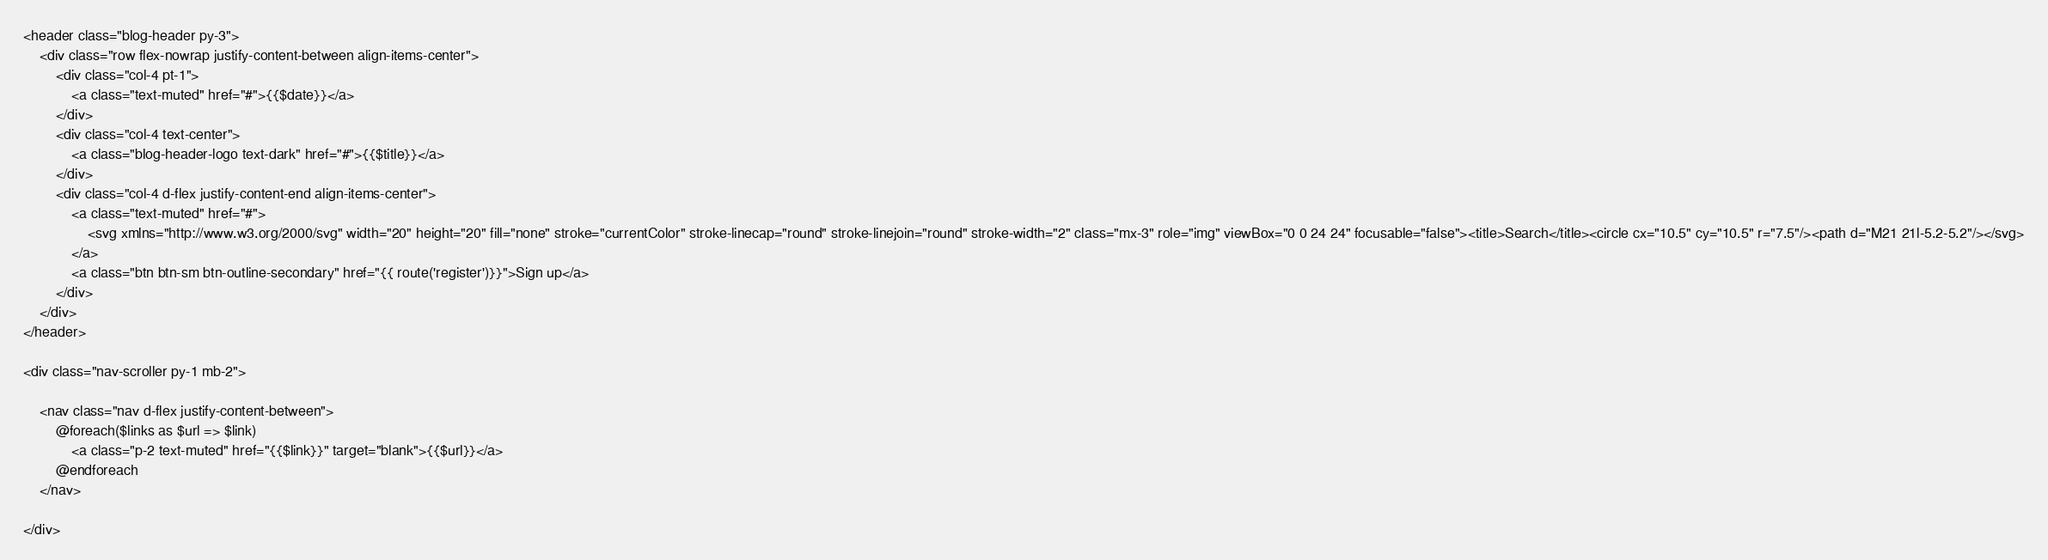<code> <loc_0><loc_0><loc_500><loc_500><_PHP_><header class="blog-header py-3">
    <div class="row flex-nowrap justify-content-between align-items-center">
        <div class="col-4 pt-1">
            <a class="text-muted" href="#">{{$date}}</a>
        </div>
        <div class="col-4 text-center">
            <a class="blog-header-logo text-dark" href="#">{{$title}}</a>
        </div>
        <div class="col-4 d-flex justify-content-end align-items-center">
            <a class="text-muted" href="#">
                <svg xmlns="http://www.w3.org/2000/svg" width="20" height="20" fill="none" stroke="currentColor" stroke-linecap="round" stroke-linejoin="round" stroke-width="2" class="mx-3" role="img" viewBox="0 0 24 24" focusable="false"><title>Search</title><circle cx="10.5" cy="10.5" r="7.5"/><path d="M21 21l-5.2-5.2"/></svg>
            </a>
            <a class="btn btn-sm btn-outline-secondary" href="{{ route('register')}}">Sign up</a>
        </div>
    </div>
</header>

<div class="nav-scroller py-1 mb-2">

    <nav class="nav d-flex justify-content-between">
        @foreach($links as $url => $link)
            <a class="p-2 text-muted" href="{{$link}}" target="blank">{{$url}}</a>
        @endforeach
    </nav>

</div></code> 